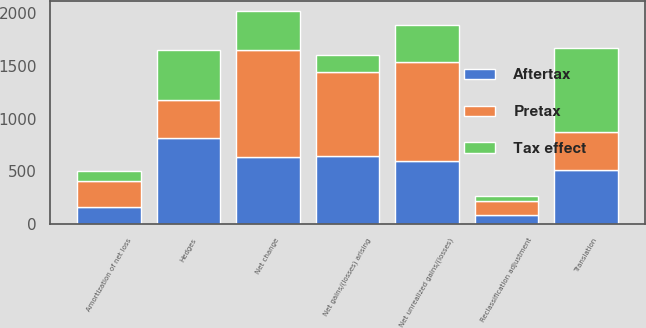Convert chart. <chart><loc_0><loc_0><loc_500><loc_500><stacked_bar_chart><ecel><fcel>Net unrealized gains/(losses)<fcel>Reclassification adjustment<fcel>Net change<fcel>Translation<fcel>Hedges<fcel>Net gains/(losses) arising<fcel>Amortization of net loss<nl><fcel>Pretax<fcel>944<fcel>134<fcel>1010<fcel>358<fcel>358<fcel>802<fcel>250<nl><fcel>Tax effect<fcel>346<fcel>50<fcel>370<fcel>801<fcel>476<fcel>160<fcel>90<nl><fcel>Aftertax<fcel>598<fcel>84<fcel>640<fcel>512<fcel>818<fcel>642<fcel>160<nl></chart> 